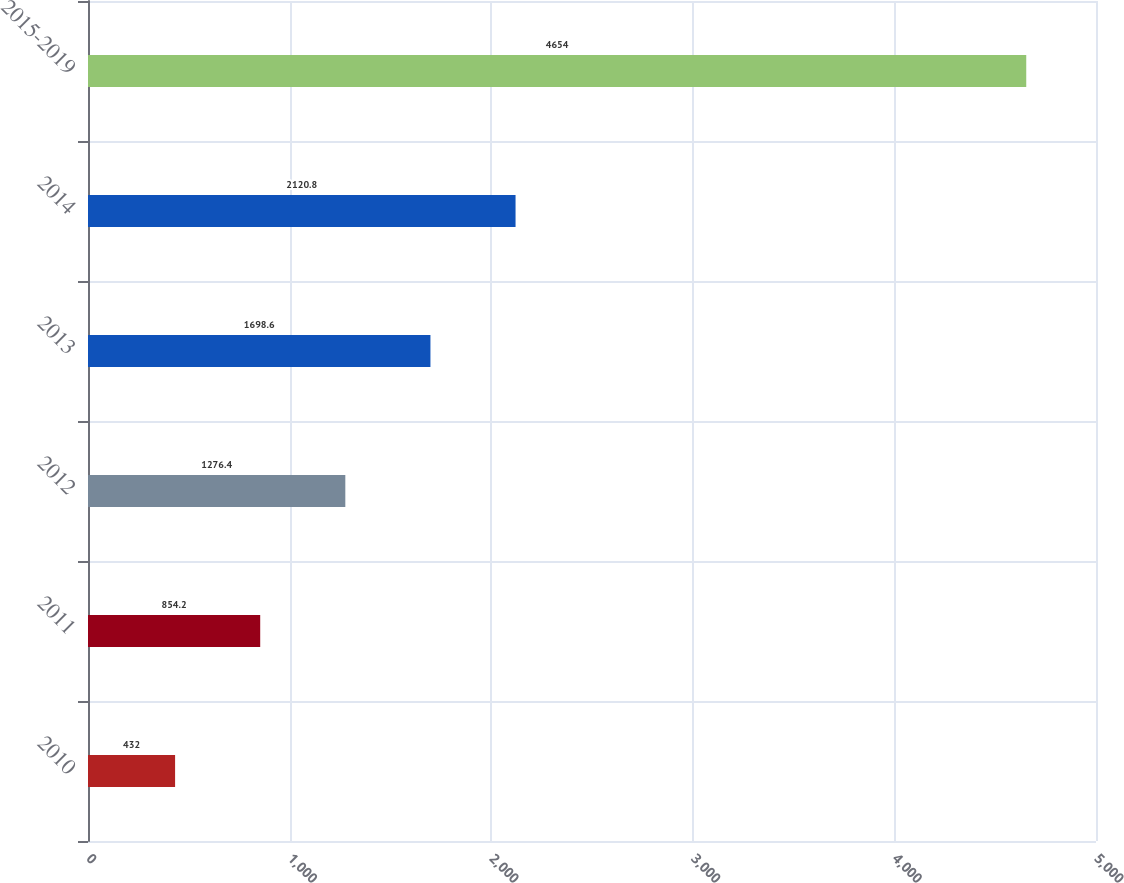Convert chart. <chart><loc_0><loc_0><loc_500><loc_500><bar_chart><fcel>2010<fcel>2011<fcel>2012<fcel>2013<fcel>2014<fcel>2015-2019<nl><fcel>432<fcel>854.2<fcel>1276.4<fcel>1698.6<fcel>2120.8<fcel>4654<nl></chart> 